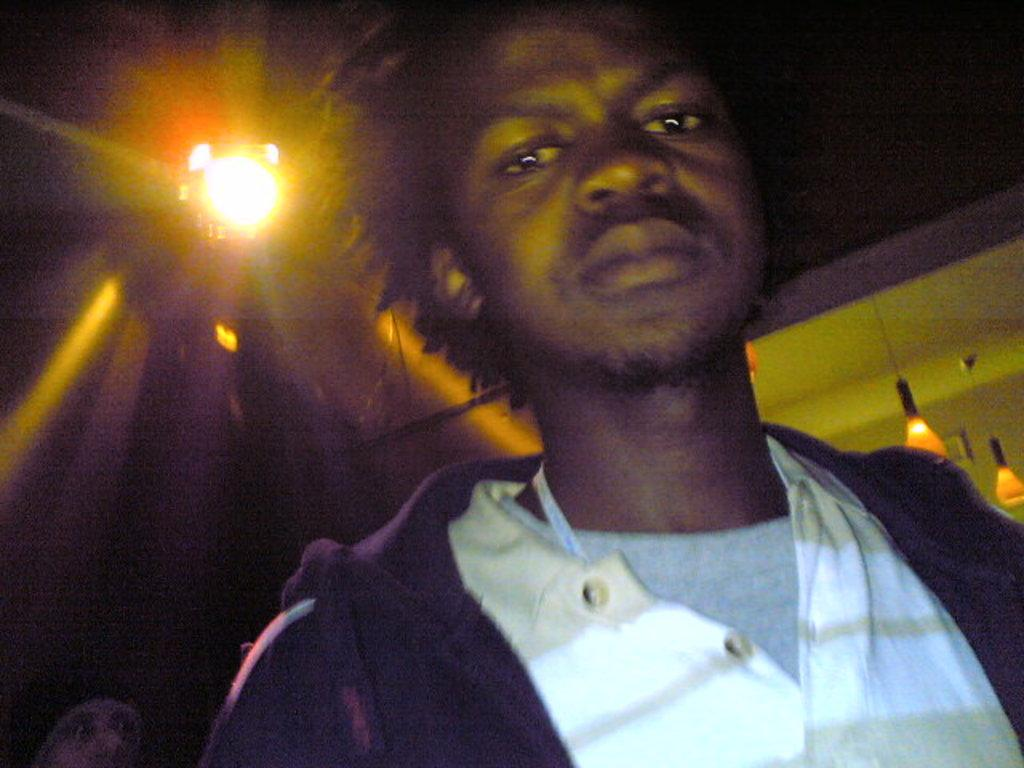What is the person in the image wearing? The person is wearing a brown color jacket. What is the person's posture in the image? The person is standing. What can be seen on the roof in the background of the image? There are lights attached to the roof in the background of the image. How would you describe the overall color of the background in the image? The background of the image is dark in color. What type of substance is being used to create the powdery effect on the person's jacket in the image? There is no powdery effect or substance present on the person's jacket in the image. 